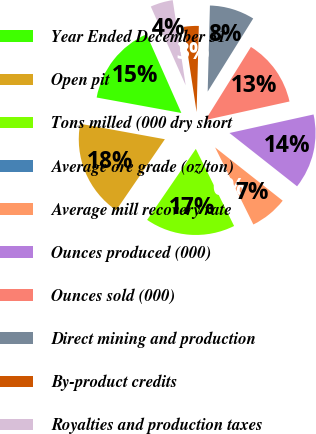Convert chart to OTSL. <chart><loc_0><loc_0><loc_500><loc_500><pie_chart><fcel>Year Ended December 31<fcel>Open pit<fcel>Tons milled (000 dry short<fcel>Average ore grade (oz/ton)<fcel>Average mill recovery rate<fcel>Ounces produced (000)<fcel>Ounces sold (000)<fcel>Direct mining and production<fcel>By-product credits<fcel>Royalties and production taxes<nl><fcel>15.49%<fcel>18.31%<fcel>16.9%<fcel>0.0%<fcel>7.04%<fcel>14.08%<fcel>12.68%<fcel>8.45%<fcel>2.82%<fcel>4.23%<nl></chart> 